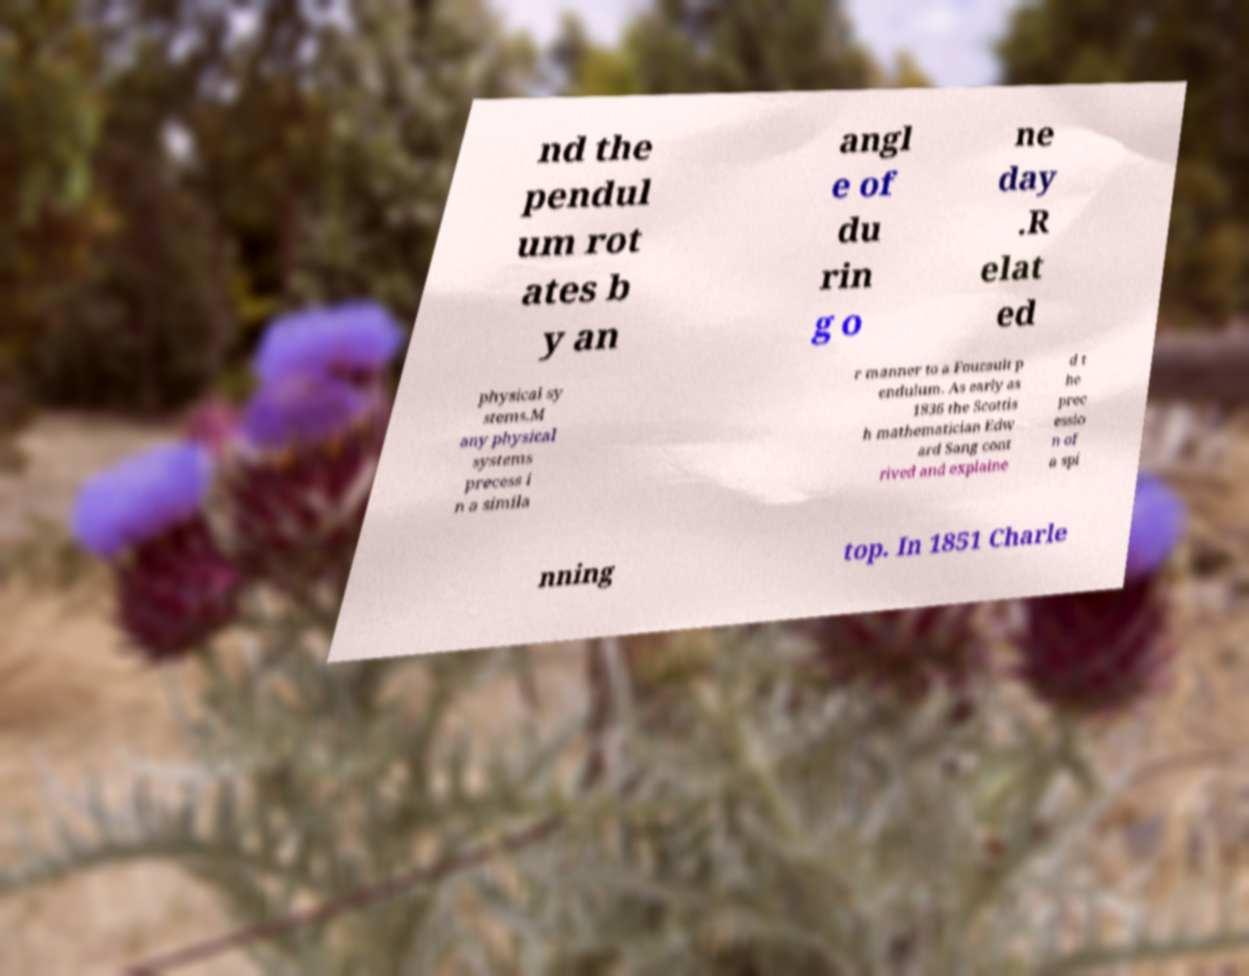Can you accurately transcribe the text from the provided image for me? nd the pendul um rot ates b y an angl e of du rin g o ne day .R elat ed physical sy stems.M any physical systems precess i n a simila r manner to a Foucault p endulum. As early as 1836 the Scottis h mathematician Edw ard Sang cont rived and explaine d t he prec essio n of a spi nning top. In 1851 Charle 